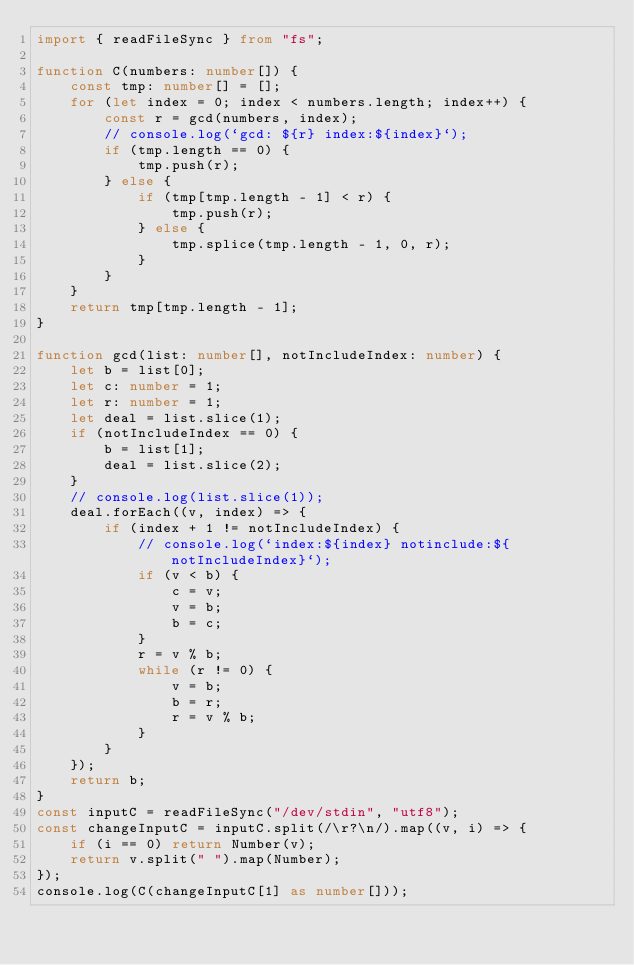<code> <loc_0><loc_0><loc_500><loc_500><_TypeScript_>import { readFileSync } from "fs";

function C(numbers: number[]) {
    const tmp: number[] = [];
    for (let index = 0; index < numbers.length; index++) {
        const r = gcd(numbers, index);
        // console.log(`gcd: ${r} index:${index}`);
        if (tmp.length == 0) {
            tmp.push(r);
        } else {
            if (tmp[tmp.length - 1] < r) {
                tmp.push(r);
            } else {
                tmp.splice(tmp.length - 1, 0, r);
            }
        }
    }
    return tmp[tmp.length - 1];
}

function gcd(list: number[], notIncludeIndex: number) {
    let b = list[0];
    let c: number = 1;
    let r: number = 1;
    let deal = list.slice(1);
    if (notIncludeIndex == 0) {
        b = list[1];
        deal = list.slice(2);
    }
    // console.log(list.slice(1));
    deal.forEach((v, index) => {
        if (index + 1 != notIncludeIndex) {
            // console.log(`index:${index} notinclude:${notIncludeIndex}`);
            if (v < b) {
                c = v;
                v = b;
                b = c;
            }
            r = v % b;
            while (r != 0) {
                v = b;
                b = r;
                r = v % b;
            }
        }
    });
    return b;
}
const inputC = readFileSync("/dev/stdin", "utf8");
const changeInputC = inputC.split(/\r?\n/).map((v, i) => {
    if (i == 0) return Number(v);
    return v.split(" ").map(Number);
});
console.log(C(changeInputC[1] as number[]));</code> 